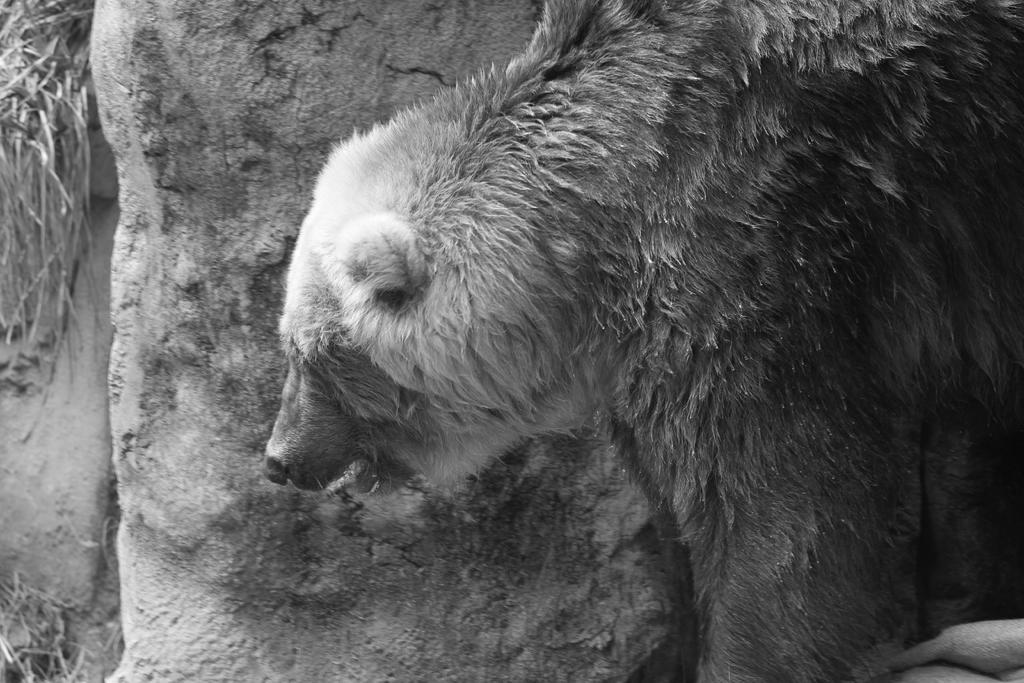What is the color scheme of the image? The image is black and white. What animal can be seen in the image? There is a bear in the image. How does the bear help the person in the image? There is no person present in the image, and the bear is not shown helping anyone. 